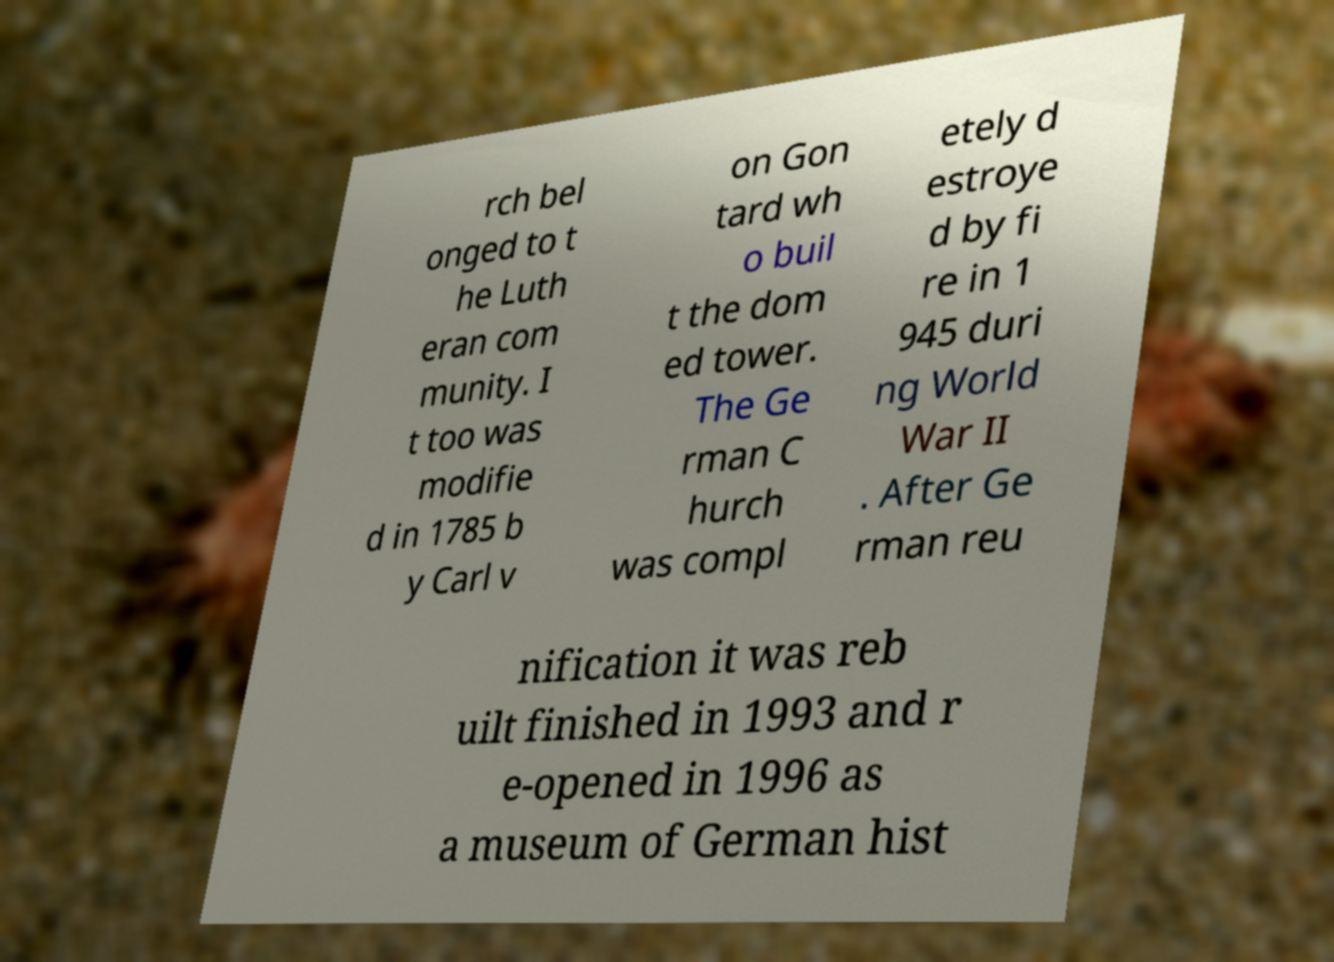I need the written content from this picture converted into text. Can you do that? rch bel onged to t he Luth eran com munity. I t too was modifie d in 1785 b y Carl v on Gon tard wh o buil t the dom ed tower. The Ge rman C hurch was compl etely d estroye d by fi re in 1 945 duri ng World War II . After Ge rman reu nification it was reb uilt finished in 1993 and r e-opened in 1996 as a museum of German hist 